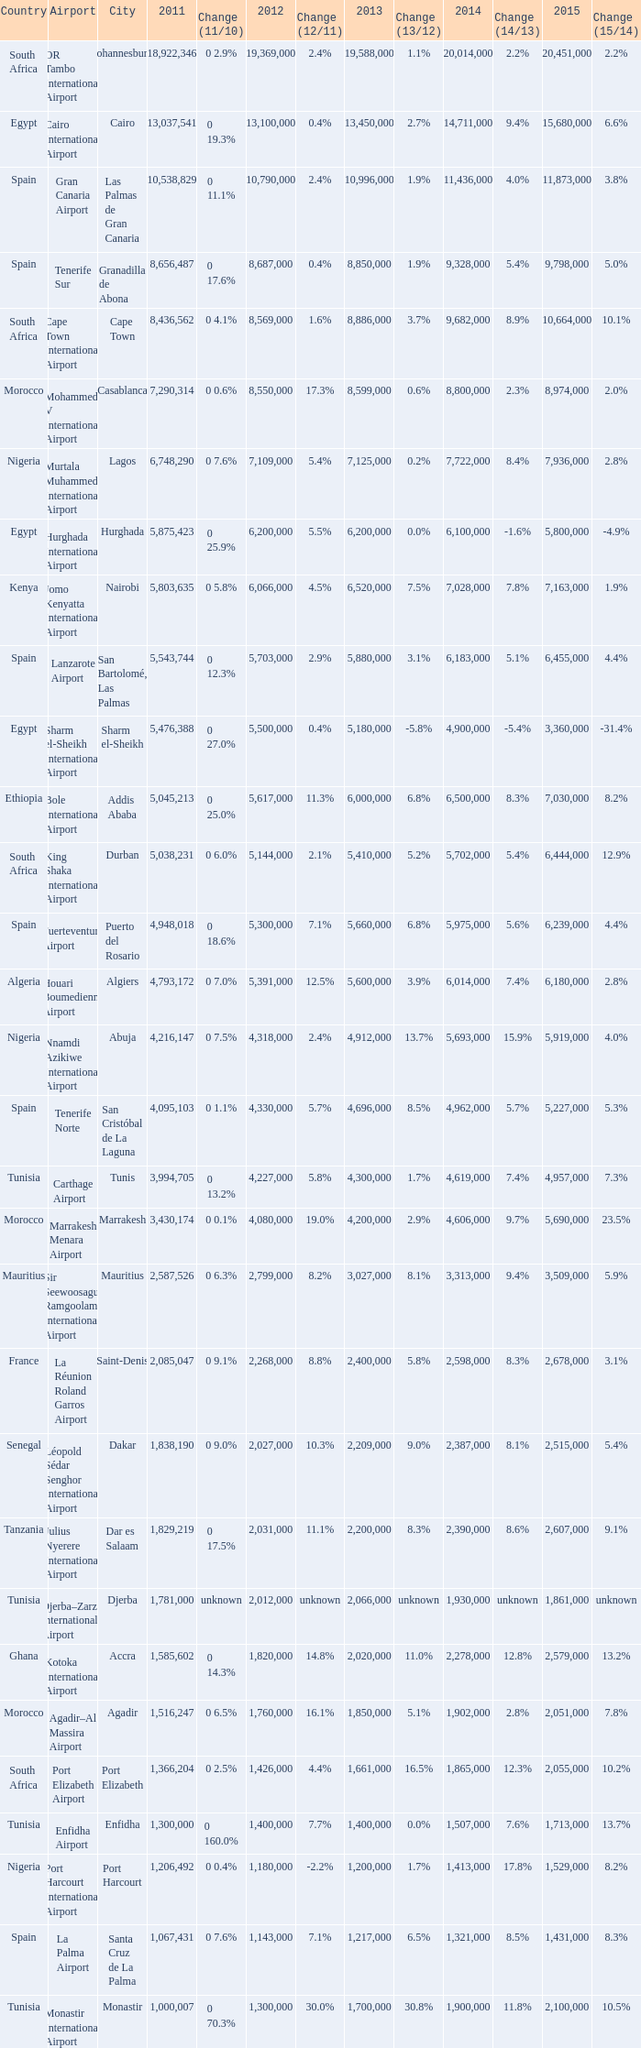Which 2011 has an Airport of bole international airport? 5045213.0. 